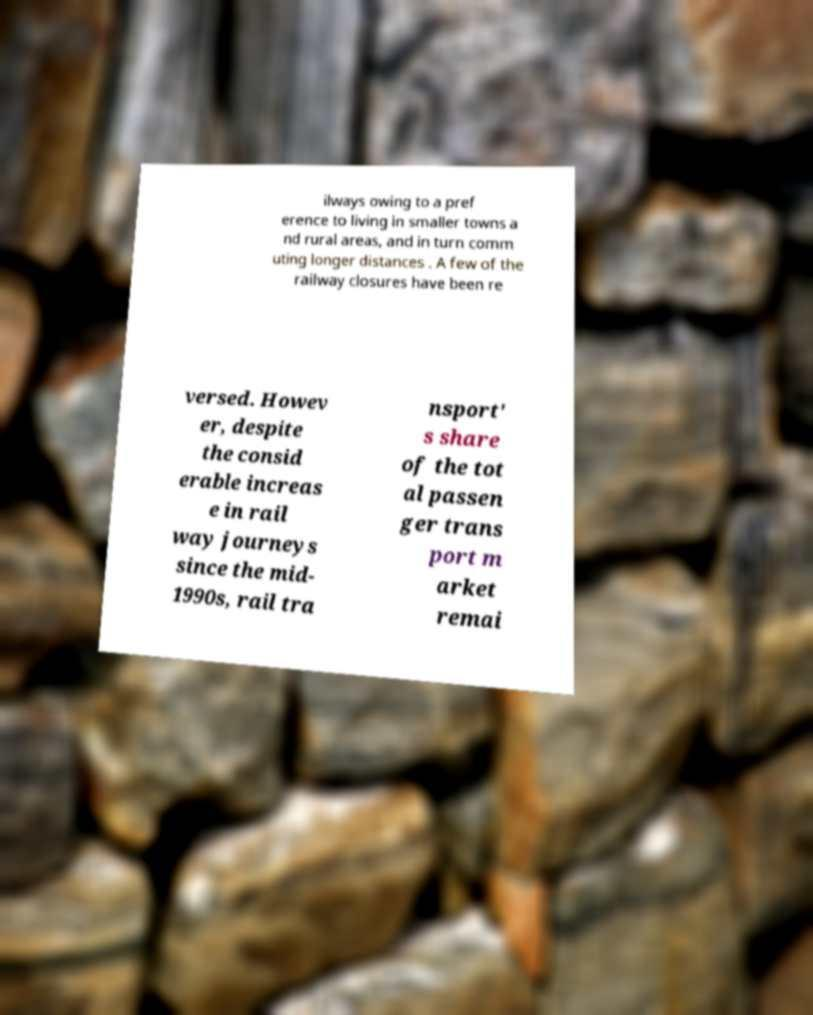For documentation purposes, I need the text within this image transcribed. Could you provide that? ilways owing to a pref erence to living in smaller towns a nd rural areas, and in turn comm uting longer distances . A few of the railway closures have been re versed. Howev er, despite the consid erable increas e in rail way journeys since the mid- 1990s, rail tra nsport' s share of the tot al passen ger trans port m arket remai 